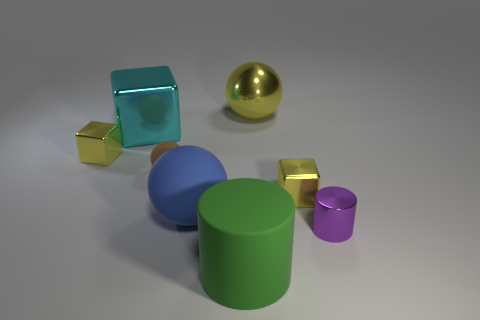Subtract all small cubes. How many cubes are left? 1 Subtract all purple cylinders. How many cylinders are left? 1 Add 1 balls. How many objects exist? 9 Subtract all purple cylinders. Subtract all brown spheres. How many cylinders are left? 1 Subtract all blue spheres. How many yellow blocks are left? 2 Subtract all blue matte balls. Subtract all small metallic cylinders. How many objects are left? 6 Add 3 yellow metal things. How many yellow metal things are left? 6 Add 7 small blue metal cylinders. How many small blue metal cylinders exist? 7 Subtract 1 green cylinders. How many objects are left? 7 Subtract all balls. How many objects are left? 5 